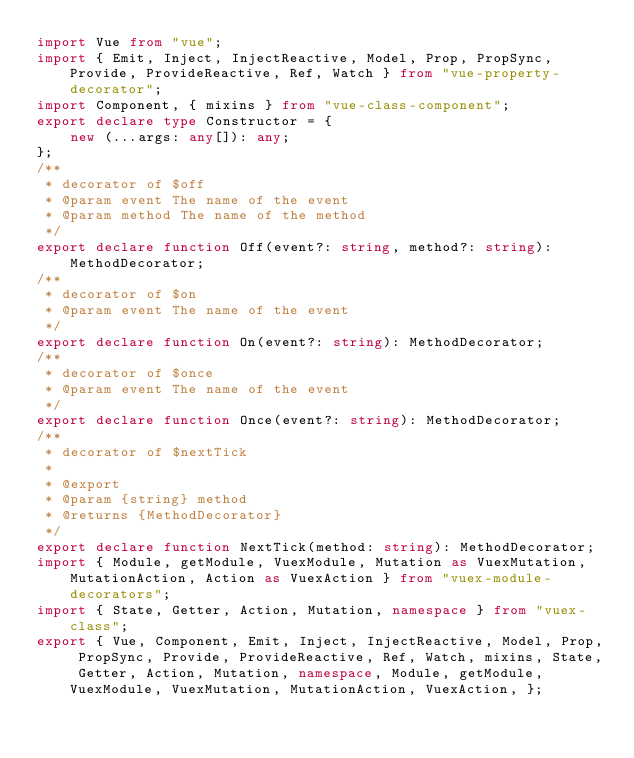Convert code to text. <code><loc_0><loc_0><loc_500><loc_500><_TypeScript_>import Vue from "vue";
import { Emit, Inject, InjectReactive, Model, Prop, PropSync, Provide, ProvideReactive, Ref, Watch } from "vue-property-decorator";
import Component, { mixins } from "vue-class-component";
export declare type Constructor = {
    new (...args: any[]): any;
};
/**
 * decorator of $off
 * @param event The name of the event
 * @param method The name of the method
 */
export declare function Off(event?: string, method?: string): MethodDecorator;
/**
 * decorator of $on
 * @param event The name of the event
 */
export declare function On(event?: string): MethodDecorator;
/**
 * decorator of $once
 * @param event The name of the event
 */
export declare function Once(event?: string): MethodDecorator;
/**
 * decorator of $nextTick
 *
 * @export
 * @param {string} method
 * @returns {MethodDecorator}
 */
export declare function NextTick(method: string): MethodDecorator;
import { Module, getModule, VuexModule, Mutation as VuexMutation, MutationAction, Action as VuexAction } from "vuex-module-decorators";
import { State, Getter, Action, Mutation, namespace } from "vuex-class";
export { Vue, Component, Emit, Inject, InjectReactive, Model, Prop, PropSync, Provide, ProvideReactive, Ref, Watch, mixins, State, Getter, Action, Mutation, namespace, Module, getModule, VuexModule, VuexMutation, MutationAction, VuexAction, };
</code> 